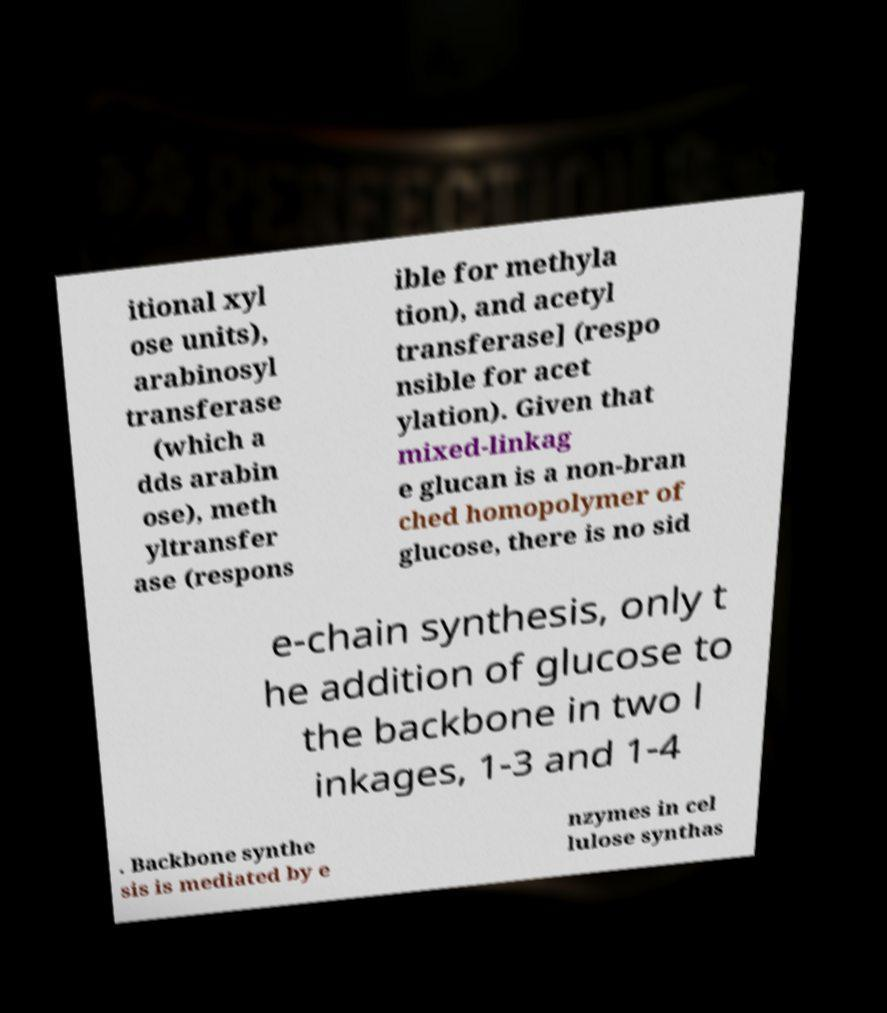Could you extract and type out the text from this image? itional xyl ose units), arabinosyl transferase (which a dds arabin ose), meth yltransfer ase (respons ible for methyla tion), and acetyl transferase] (respo nsible for acet ylation). Given that mixed-linkag e glucan is a non-bran ched homopolymer of glucose, there is no sid e-chain synthesis, only t he addition of glucose to the backbone in two l inkages, 1-3 and 1-4 . Backbone synthe sis is mediated by e nzymes in cel lulose synthas 